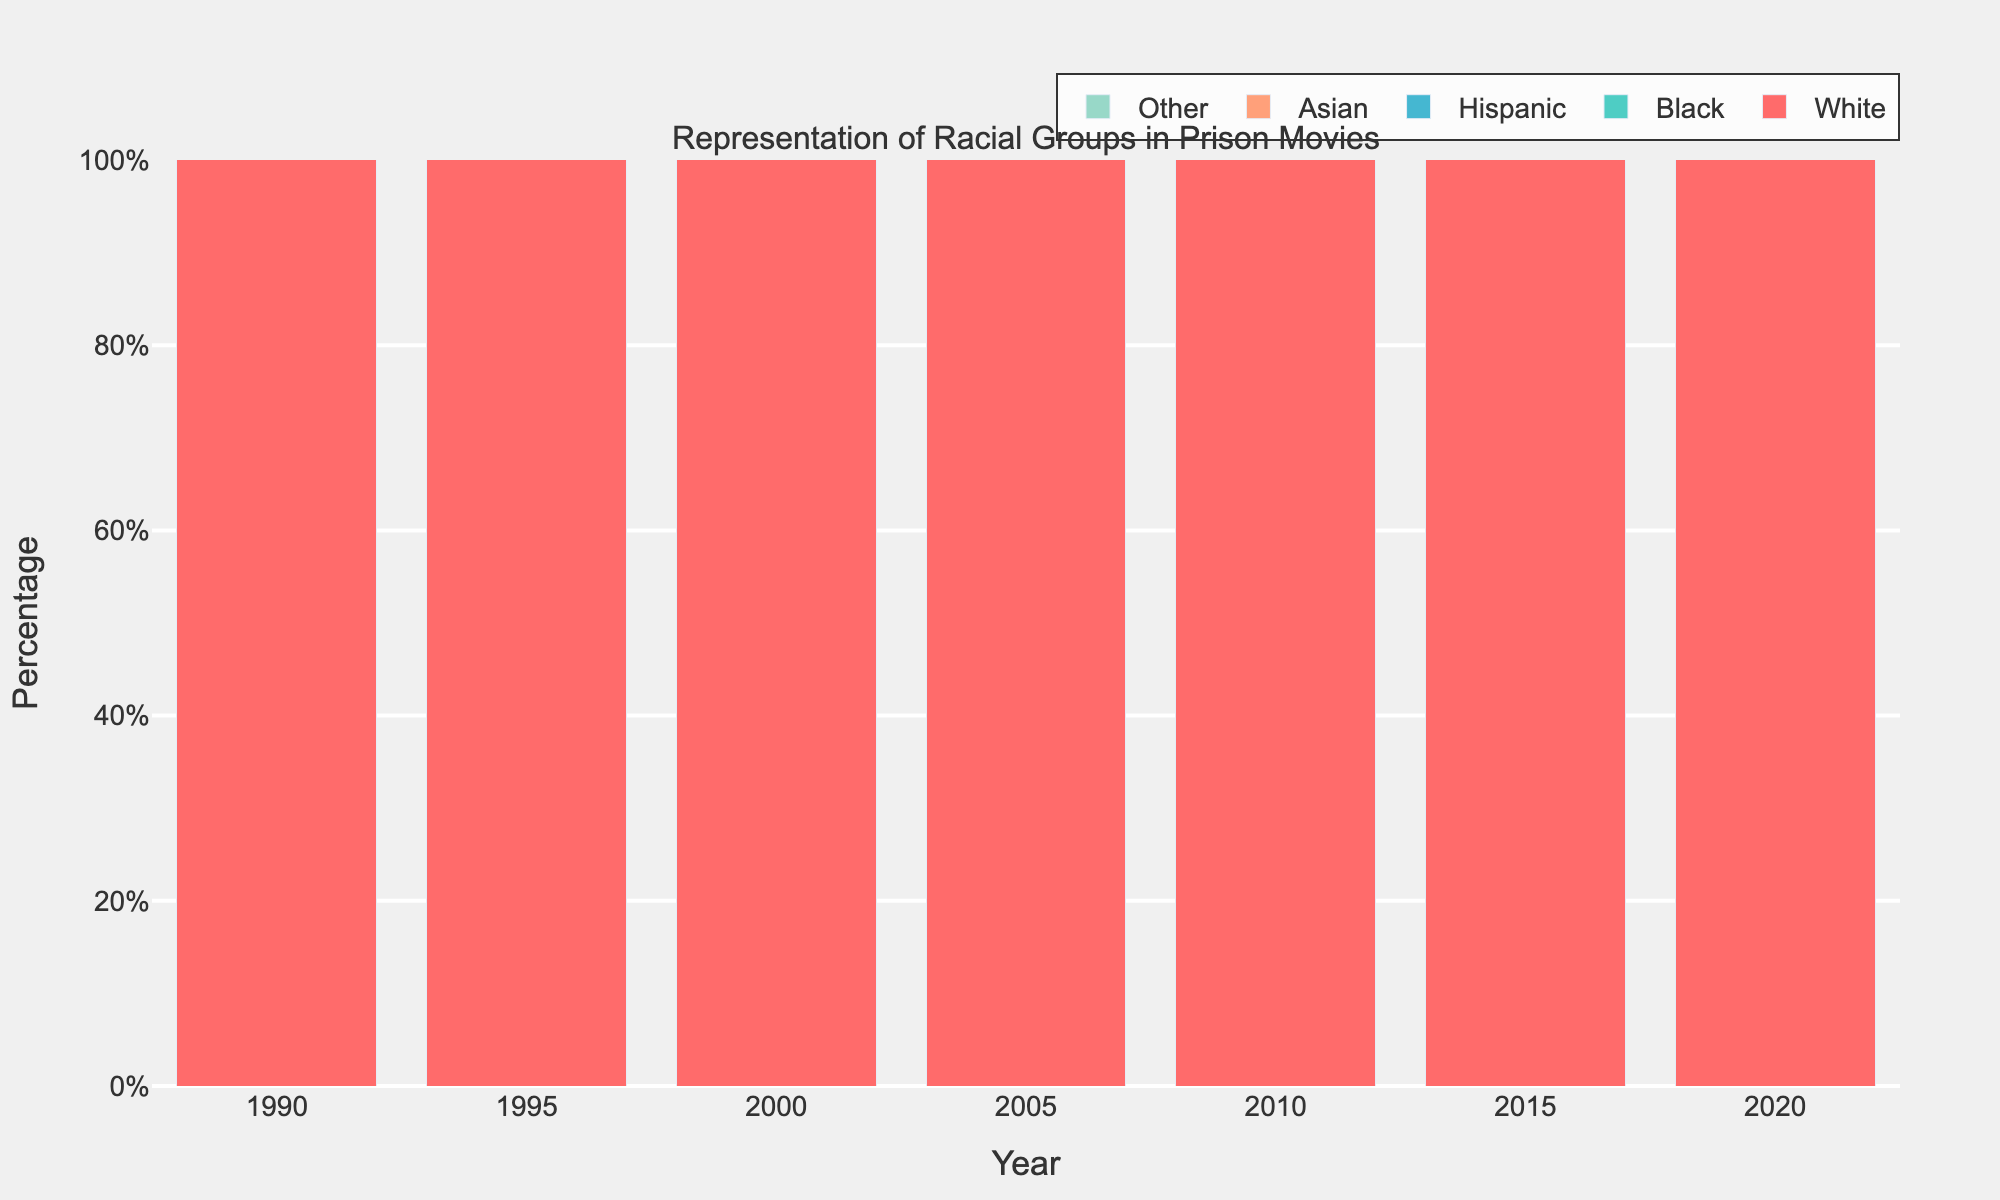What's the difference in the representation of White and Black groups in 1990? In 1990, the representation of the White group is 45% and the representation of the Black group is 35%. The difference is 45% - 35%.
Answer: 10% Which racial group shows the most significant increase in representation from 1990 to 2020? To determine the most significant increase, compare the initial and final representation values for each group over the time period. White: 45% to 30% (decrease), Black: 35% to 46% (increase), Hispanic: 15% to 20% (increase), Asian: 3% to 3% (no change), Other: 2% to 1% (decrease). The Black group shows the most significant increase from 35% to 46%.
Answer: Black How has the representation of Hispanic racial groups changed from 1990 to 2020? In 1990, the representation of the Hispanic group is 15%. In 2020, it is 20%. The change can be calculated as 20% - 15%.
Answer: 5% Which year shows the highest representation of Asian racial groups? Inspect the bars for the Asian group across the years to find the highest point. The representation for Asian groups remained at 3% in 1990, 1995, 2000, 2020, and dipped to 2% in 2005, 2010, and 2015.
Answer: 1990, 1995, 2000, 2020 Between which consecutive years did the Black representation increase the most? Calculate the difference in Black representation between consecutive years: 1990-1995 (38% - 35%), 1995-2000 (40% - 38%), 2000-2005 (42% - 40%), 2005-2010 (44% - 42%), 2010-2015 (45% - 44%), and 2015-2020 (46% - 45%). The largest increase is between 1990 and 1995: 38% - 35% = 3%.
Answer: 1990-1995 What is the total representation percentage for minority groups (Black, Hispanic, Asian, Other) in 2020? Sum the percentages for Black, Hispanic, Asian, and Other groups in 2020: 46% + 20% + 3% + 1%.
Answer: 70% Which racial group consistently decreased in representation over the decades from 1990 to 2020? By examining the heights of the bars for each racial group across different years, we can see that the White group shows a consistent decrease: 45% (1990), 42% (1995), 40% (2000), 38% (2005), 35% (2010), 33% (2015), 30% (2020).
Answer: White Compare the representation of Black and Hispanic racial groups in 2010. The bar heights for Black and Hispanic groups in 2010 show 44% and 18% respectively.
Answer: Black 44%, Hispanic 18% Across three decades, which racial group's representation remains almost stagnant? Analyze the changes in each group's representation over the 30 years. Asian group representation shows minimal fluctuation: 1990, 1995, 2000, 2020 (3%), and 2005, 2010, 2015 (2%).
Answer: Asian 